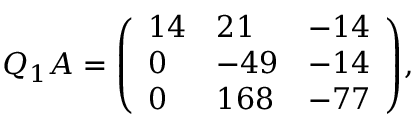Convert formula to latex. <formula><loc_0><loc_0><loc_500><loc_500>Q _ { 1 } A = { \left ( \begin{array} { l l l } { 1 4 } & { 2 1 } & { - 1 4 } \\ { 0 } & { - 4 9 } & { - 1 4 } \\ { 0 } & { 1 6 8 } & { - 7 7 } \end{array} \right ) } ,</formula> 